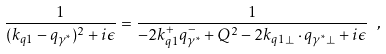<formula> <loc_0><loc_0><loc_500><loc_500>\frac { 1 } { ( k _ { q 1 } - q _ { \gamma ^ { * } } ) ^ { 2 } + i \epsilon } = \frac { 1 } { - 2 k _ { q 1 } ^ { + } q _ { \gamma ^ { * } } ^ { - } + Q ^ { 2 } - 2 k _ { q 1 \perp } \cdot q _ { \gamma ^ { * } \perp } + i \epsilon } \ ,</formula> 